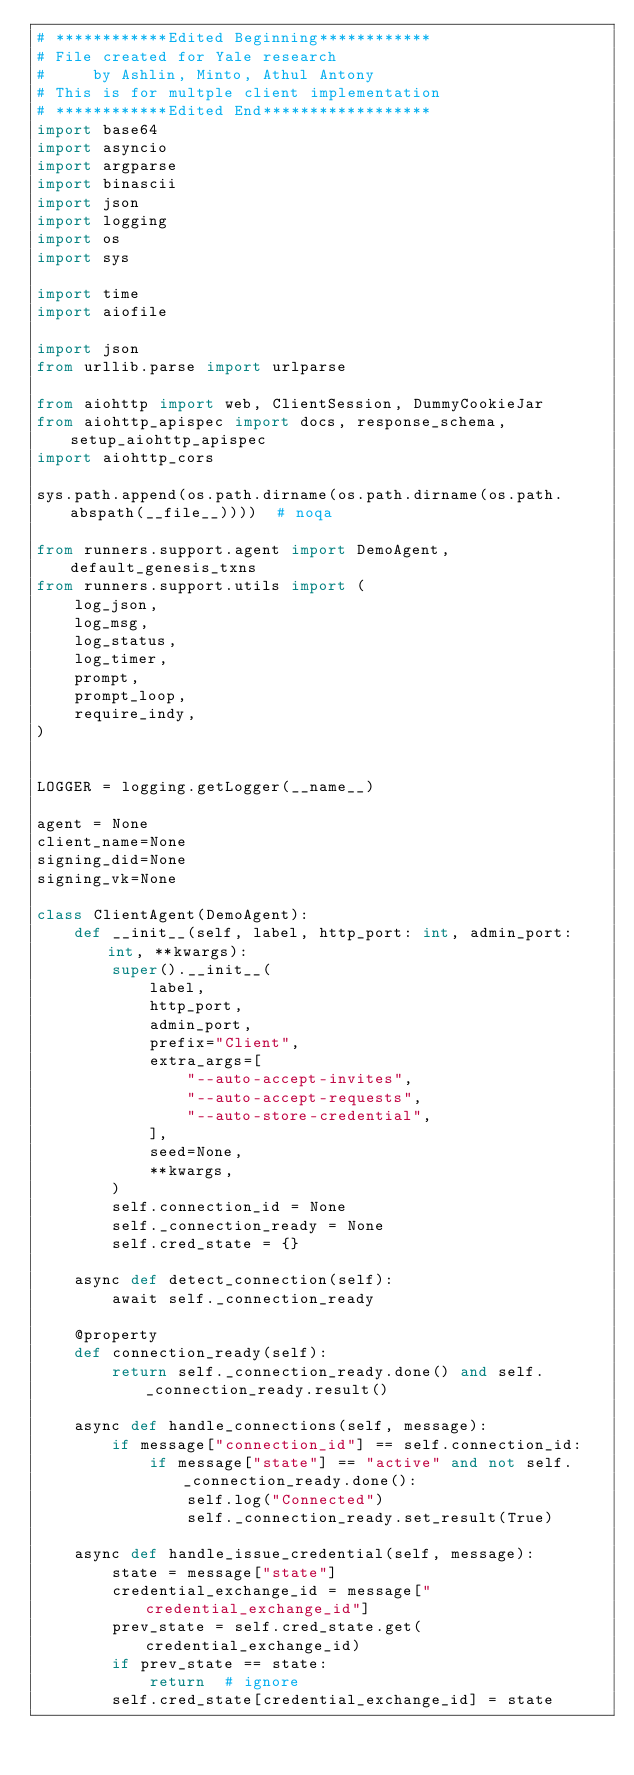Convert code to text. <code><loc_0><loc_0><loc_500><loc_500><_Python_># ************Edited Beginning************
# File created for Yale research
#     by Ashlin, Minto, Athul Antony
# This is for multple client implementation
# ************Edited End******************
import base64
import asyncio
import argparse
import binascii
import json
import logging
import os
import sys

import time
import aiofile

import json
from urllib.parse import urlparse

from aiohttp import web, ClientSession, DummyCookieJar
from aiohttp_apispec import docs, response_schema, setup_aiohttp_apispec
import aiohttp_cors

sys.path.append(os.path.dirname(os.path.dirname(os.path.abspath(__file__))))  # noqa

from runners.support.agent import DemoAgent, default_genesis_txns
from runners.support.utils import (
    log_json,
    log_msg,
    log_status,
    log_timer,
    prompt,
    prompt_loop,
    require_indy,
)


LOGGER = logging.getLogger(__name__)

agent = None
client_name=None
signing_did=None
signing_vk=None

class ClientAgent(DemoAgent):
    def __init__(self, label, http_port: int, admin_port: int, **kwargs):
        super().__init__(
            label,
            http_port,
            admin_port,
            prefix="Client",
            extra_args=[
                "--auto-accept-invites",
                "--auto-accept-requests",
                "--auto-store-credential",
            ],
            seed=None,
            **kwargs,
        )
        self.connection_id = None
        self._connection_ready = None
        self.cred_state = {}

    async def detect_connection(self):
        await self._connection_ready

    @property
    def connection_ready(self):
        return self._connection_ready.done() and self._connection_ready.result()

    async def handle_connections(self, message):
        if message["connection_id"] == self.connection_id:
            if message["state"] == "active" and not self._connection_ready.done():
                self.log("Connected")
                self._connection_ready.set_result(True)

    async def handle_issue_credential(self, message):
        state = message["state"]
        credential_exchange_id = message["credential_exchange_id"]
        prev_state = self.cred_state.get(credential_exchange_id)
        if prev_state == state:
            return  # ignore
        self.cred_state[credential_exchange_id] = state
</code> 